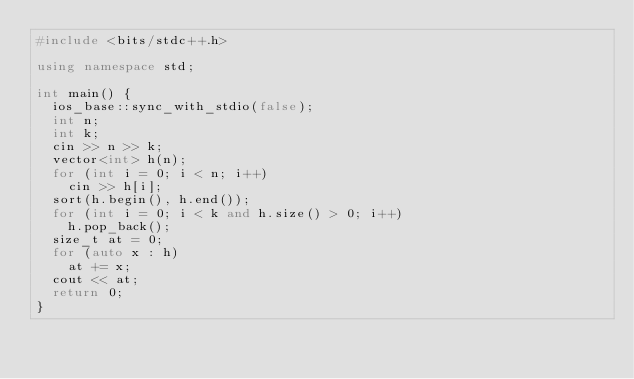Convert code to text. <code><loc_0><loc_0><loc_500><loc_500><_C++_>#include <bits/stdc++.h>

using namespace std;

int main() {
	ios_base::sync_with_stdio(false);
	int n;
	int k;
	cin >> n >> k;
	vector<int> h(n);
	for (int i = 0; i < n; i++)
		cin >> h[i];
	sort(h.begin(), h.end());
	for (int i = 0; i < k and h.size() > 0; i++)
		h.pop_back();
	size_t at = 0;
	for (auto x : h)
		at += x;
	cout << at;
	return 0;
}</code> 